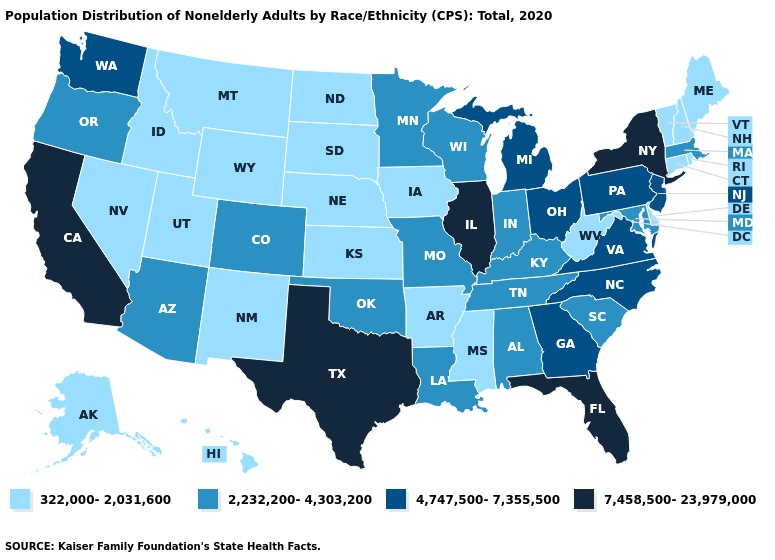Is the legend a continuous bar?
Concise answer only. No. What is the value of Vermont?
Short answer required. 322,000-2,031,600. Name the states that have a value in the range 322,000-2,031,600?
Short answer required. Alaska, Arkansas, Connecticut, Delaware, Hawaii, Idaho, Iowa, Kansas, Maine, Mississippi, Montana, Nebraska, Nevada, New Hampshire, New Mexico, North Dakota, Rhode Island, South Dakota, Utah, Vermont, West Virginia, Wyoming. What is the highest value in states that border Massachusetts?
Be succinct. 7,458,500-23,979,000. Among the states that border Illinois , which have the lowest value?
Quick response, please. Iowa. Is the legend a continuous bar?
Be succinct. No. Among the states that border West Virginia , which have the highest value?
Quick response, please. Ohio, Pennsylvania, Virginia. Name the states that have a value in the range 2,232,200-4,303,200?
Give a very brief answer. Alabama, Arizona, Colorado, Indiana, Kentucky, Louisiana, Maryland, Massachusetts, Minnesota, Missouri, Oklahoma, Oregon, South Carolina, Tennessee, Wisconsin. Does California have the highest value in the USA?
Short answer required. Yes. Does the first symbol in the legend represent the smallest category?
Short answer required. Yes. What is the lowest value in the Northeast?
Keep it brief. 322,000-2,031,600. What is the value of Hawaii?
Quick response, please. 322,000-2,031,600. Among the states that border Connecticut , does New York have the highest value?
Concise answer only. Yes. What is the highest value in the Northeast ?
Write a very short answer. 7,458,500-23,979,000. Name the states that have a value in the range 2,232,200-4,303,200?
Answer briefly. Alabama, Arizona, Colorado, Indiana, Kentucky, Louisiana, Maryland, Massachusetts, Minnesota, Missouri, Oklahoma, Oregon, South Carolina, Tennessee, Wisconsin. 